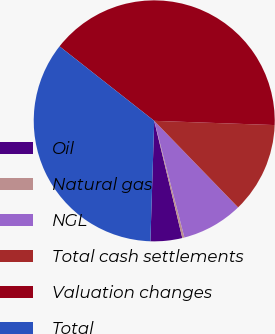Convert chart to OTSL. <chart><loc_0><loc_0><loc_500><loc_500><pie_chart><fcel>Oil<fcel>Natural gas<fcel>NGL<fcel>Total cash settlements<fcel>Valuation changes<fcel>Total<nl><fcel>4.25%<fcel>0.29%<fcel>8.22%<fcel>12.19%<fcel>39.95%<fcel>35.1%<nl></chart> 